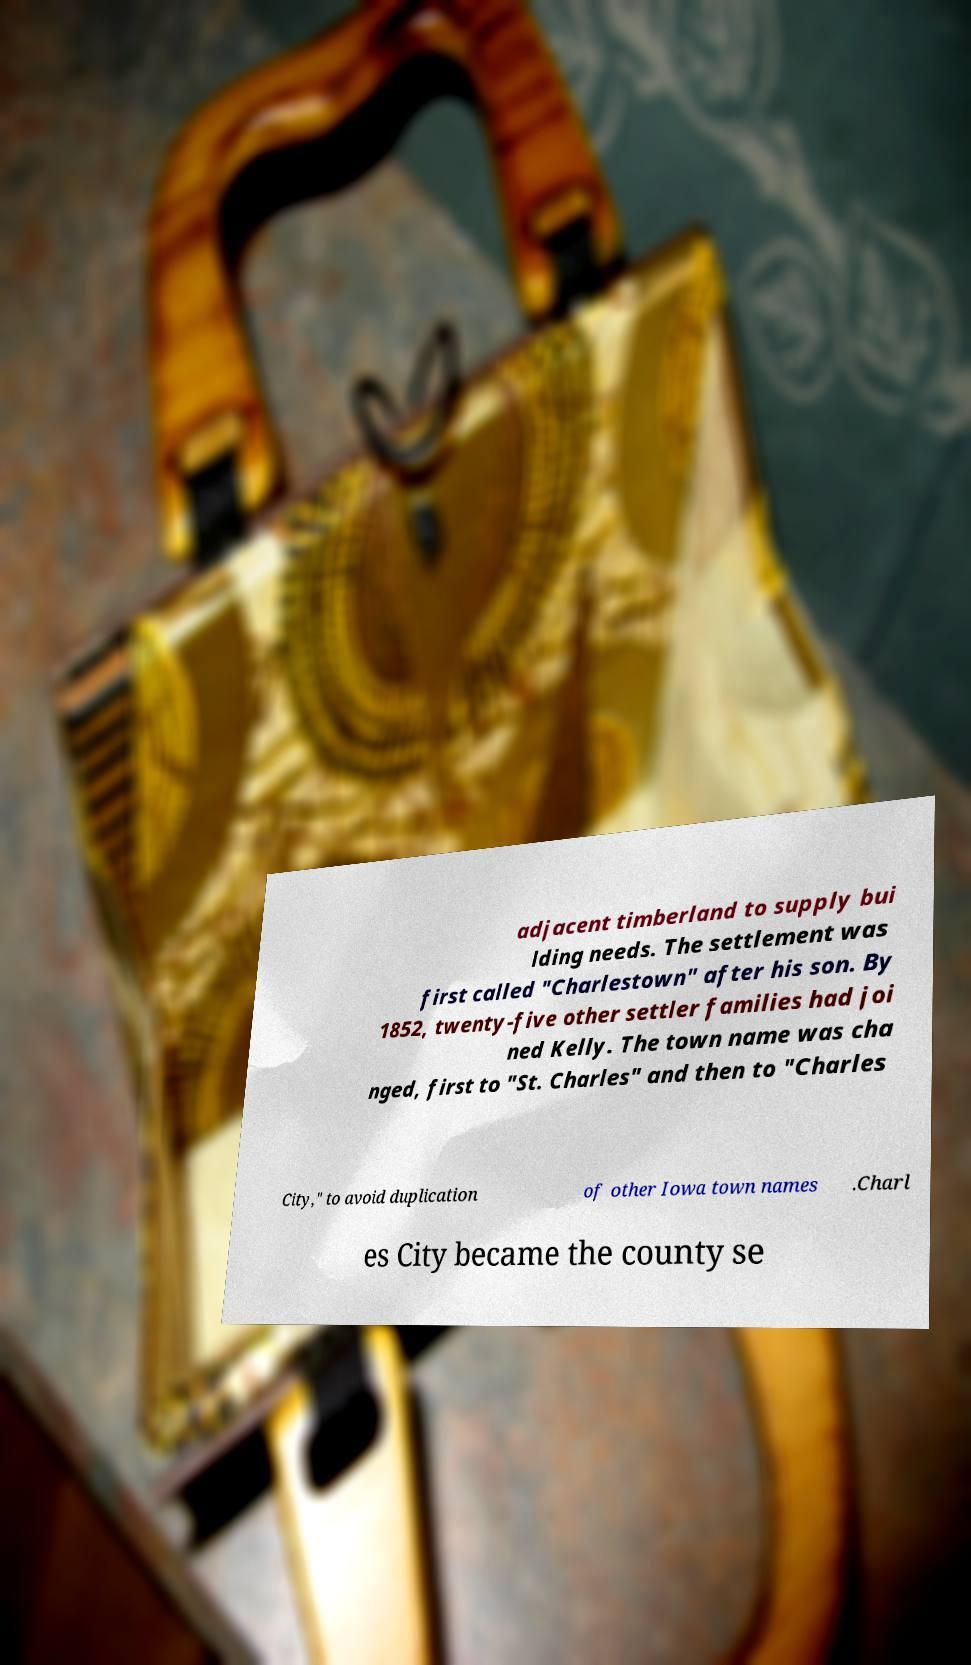Please identify and transcribe the text found in this image. adjacent timberland to supply bui lding needs. The settlement was first called "Charlestown" after his son. By 1852, twenty-five other settler families had joi ned Kelly. The town name was cha nged, first to "St. Charles" and then to "Charles City," to avoid duplication of other Iowa town names .Charl es City became the county se 